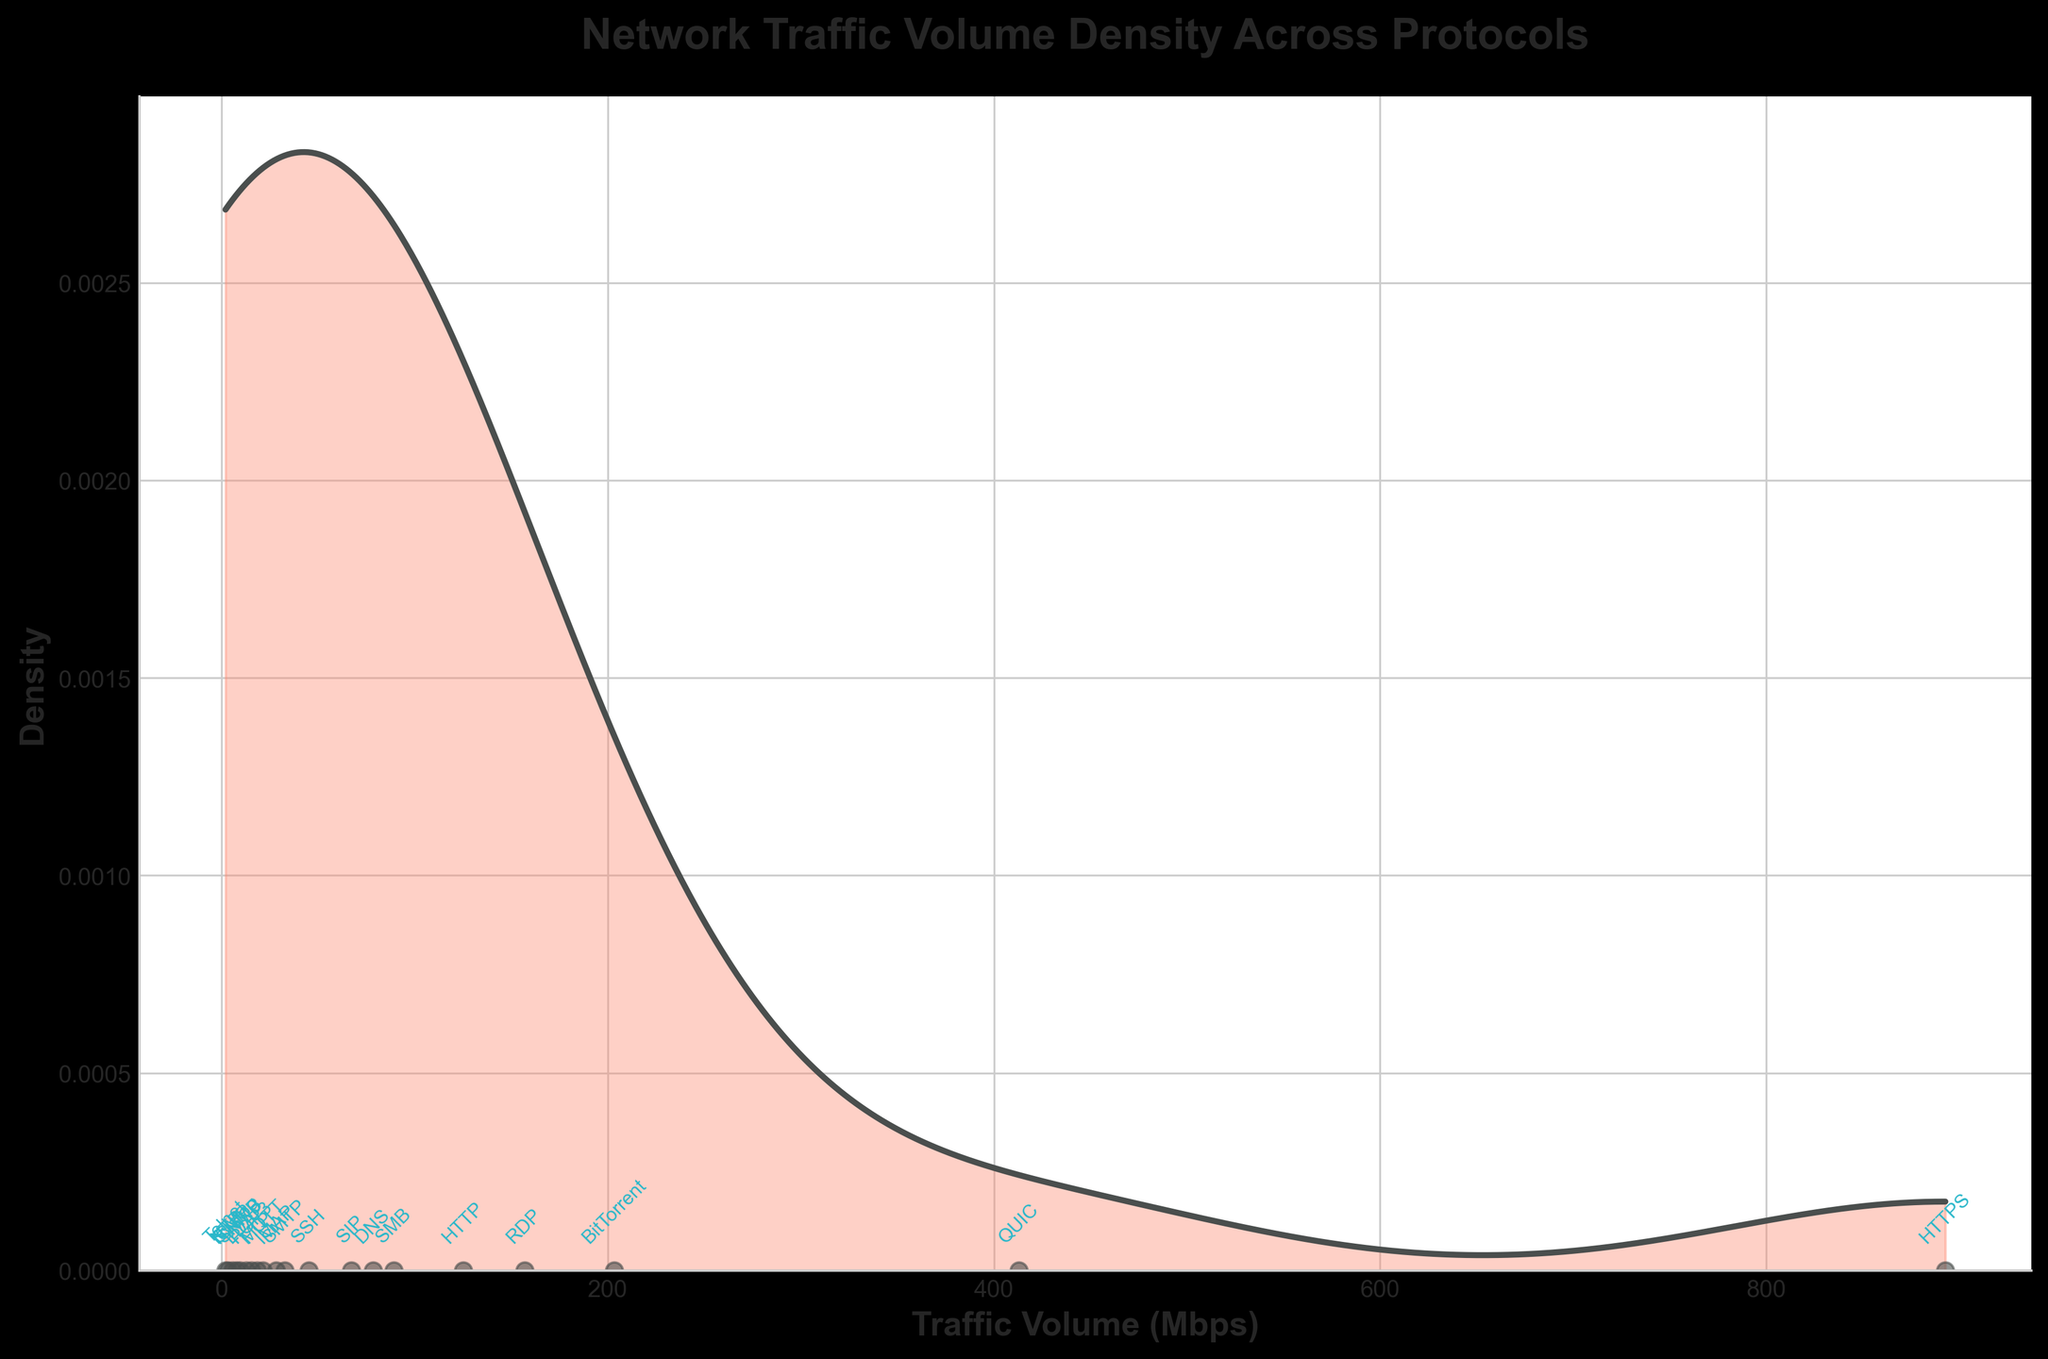What is the title of the plot? The title is displayed at the top center of the plot. It states "Network Traffic Volume Density Across Protocols".
Answer: Network Traffic Volume Density Across Protocols What are the units on the x-axis? The x-axis label is "Traffic Volume (Mbps)", which indicates that the units of measurement for traffic volume are megabits per second (Mbps).
Answer: Mbps What protocol corresponds to the highest traffic volume? By observing the scatter plot at the base of the density plot, the protocol with the highest traffic volume is "HTTPS" at approximately 892.7 Mbps.
Answer: HTTPS How many distinct protocols are annotated in the plot? By counting the annotations along the x-axis, there are 20 distinct protocols displayed in the plot.
Answer: 20 Which protocol has the lowest traffic volume, and what is its value? The scatter plot indicates that the protocol with the lowest traffic volume is "Telnet" at approximately 2.1 Mbps.
Answer: Telnet, 2.1 Mbps What is the range of the traffic volumes in this plot? The lowest traffic volume (Telnet) is 2.1 Mbps, and the highest traffic volume (HTTPS) is 892.7 Mbps. Subtracting the lowest from the highest gives the range: 892.7 - 2.1 = 890.6 Mbps.
Answer: 890.6 Mbps Which protocols have traffic volumes higher than 200 Mbps? Examining the protocols along the x-axis, protocols with traffic volumes exceeding 200 Mbps are "HTTPS" (892.7 Mbps), "BitTorrent" (203.5 Mbps), and "QUIC" (412.8 Mbps).
Answer: HTTPS, BitTorrent, QUIC What can you infer about the density of traffic volumes around 100 Mbps? Referencing the density curve, there is a noticeable peak around the 100 Mbps region, indicating that several protocols have traffic volumes close to this value.
Answer: There is a peak Between "HTTP" and "RDP", which protocol has a higher traffic volume? Observing the annotated scatter plot, "RDP" has a higher traffic volume (156.9 Mbps) compared to "HTTP" (125.3 Mbps).
Answer: RDP Which protocol has a traffic volume close to the median of all recorded traffic volumes? To find the median, the traffic volumes should be sorted, and the middle value is taken. After sorting, the approximate median falls around the traffic volume of "BitTorrent" (203.5 Mbps).
Answer: BitTorrent 